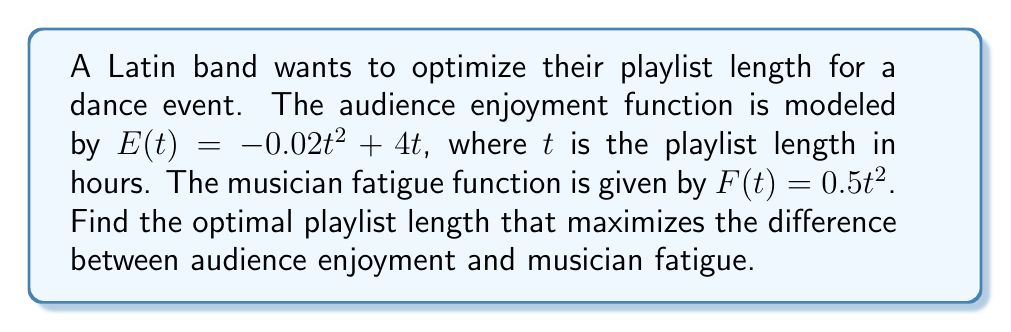Show me your answer to this math problem. To find the optimal playlist length, we need to maximize the difference between audience enjoyment and musician fatigue. Let's call this difference function $D(t)$.

1) First, we define $D(t)$:
   $D(t) = E(t) - F(t) = (-0.02t^2 + 4t) - (0.5t^2)$
   $D(t) = -0.52t^2 + 4t$

2) To find the maximum of $D(t)$, we need to find where its derivative equals zero:
   $D'(t) = -1.04t + 4$

3) Set $D'(t) = 0$ and solve for $t$:
   $-1.04t + 4 = 0$
   $-1.04t = -4$
   $t = \frac{4}{1.04} \approx 3.85$

4) To confirm this is a maximum, we can check the second derivative:
   $D''(t) = -1.04$, which is negative, confirming a maximum.

5) Therefore, the optimal playlist length is approximately 3.85 hours or 3 hours and 51 minutes.
Answer: The optimal playlist length is approximately 3.85 hours or 3 hours and 51 minutes. 